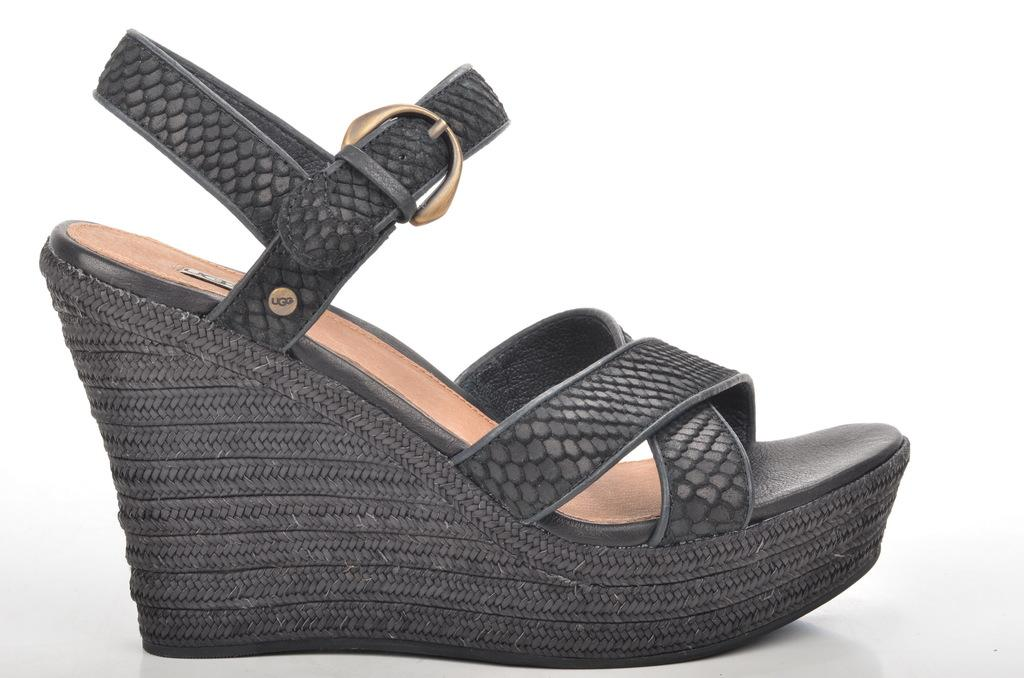What type of footwear is featured in the image? There is a black color ladies heel sandal in the image. Can you describe the style or design of the sandal? The provided facts do not specify the style or design of the sandal, only its color and type. Is the sandal worn by someone in the image? The facts do not mention whether the sandal is being worn or not. What type of adjustment can be made to the sandal to improve its comfort? The image does not show any adjustment options for the sandal, nor does it provide information about the sandal's comfort. --- 